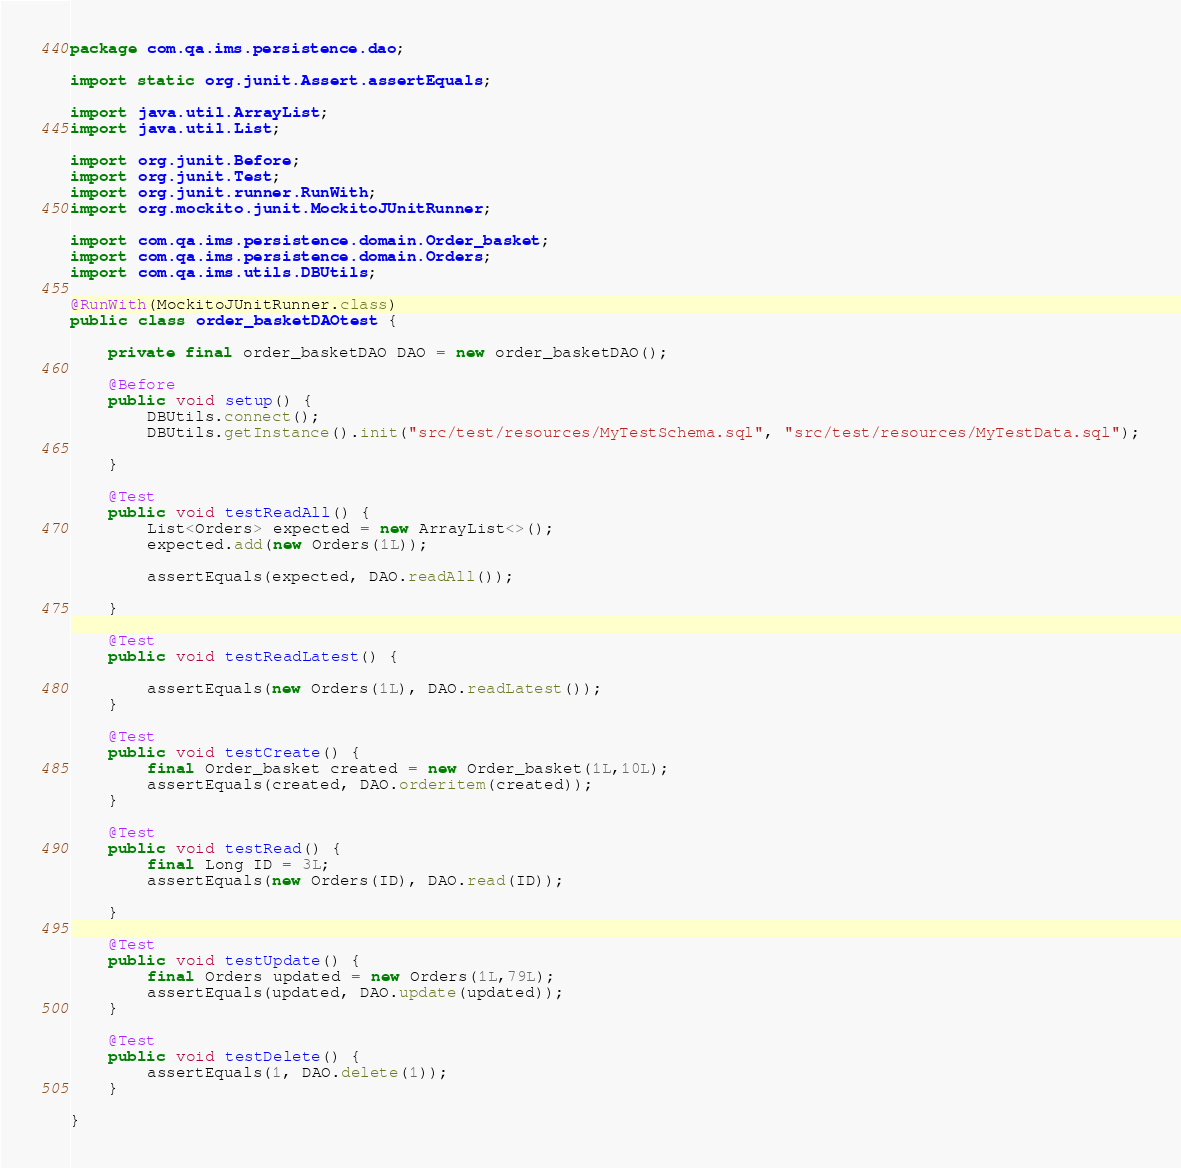Convert code to text. <code><loc_0><loc_0><loc_500><loc_500><_Java_>package com.qa.ims.persistence.dao;

import static org.junit.Assert.assertEquals;

import java.util.ArrayList;
import java.util.List;

import org.junit.Before;
import org.junit.Test;
import org.junit.runner.RunWith;
import org.mockito.junit.MockitoJUnitRunner;

import com.qa.ims.persistence.domain.Order_basket;
import com.qa.ims.persistence.domain.Orders;
import com.qa.ims.utils.DBUtils;

@RunWith(MockitoJUnitRunner.class)
public class order_basketDAOtest {

	private final order_basketDAO DAO = new order_basketDAO();

	@Before
	public void setup() {
		DBUtils.connect();
		DBUtils.getInstance().init("src/test/resources/MyTestSchema.sql", "src/test/resources/MyTestData.sql");

	}

	@Test
	public void testReadAll() {
		List<Orders> expected = new ArrayList<>();
		expected.add(new Orders(1L));

		assertEquals(expected, DAO.readAll());
		
	}

	@Test
	public void testReadLatest() {
		
		assertEquals(new Orders(1L), DAO.readLatest());
	}

	@Test
	public void testCreate() {
		final Order_basket created = new Order_basket(1L,10L);
		assertEquals(created, DAO.orderitem(created));
	}

	@Test
	public void testRead() {
		final Long ID = 3L;
		assertEquals(new Orders(ID), DAO.read(ID));

	}

	@Test
	public void testUpdate() {
		final Orders updated = new Orders(1L,79L);
		assertEquals(updated, DAO.update(updated));
	}

	@Test
	public void testDelete() {
		assertEquals(1, DAO.delete(1));
	}

}
</code> 